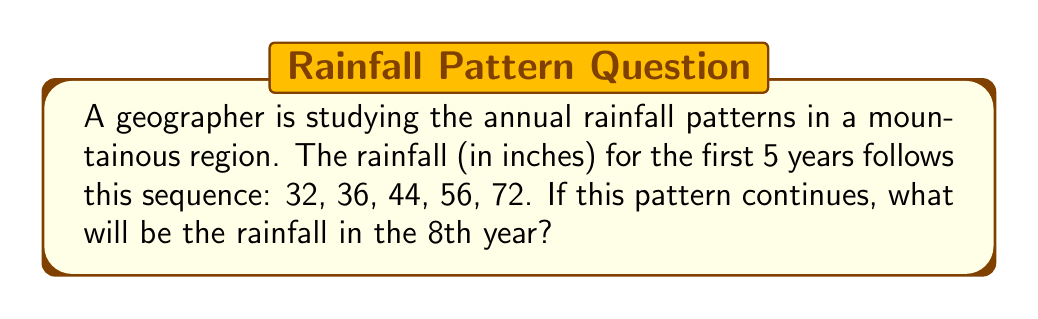Can you answer this question? To solve this problem, let's follow these steps:

1) First, we need to identify the pattern in the given sequence:
   32, 36, 44, 56, 72

2) Let's calculate the differences between consecutive terms:
   36 - 32 = 4
   44 - 36 = 8
   56 - 44 = 12
   72 - 56 = 16

3) We can see that the differences are increasing by 4 each time:
   4, 8, 12, 16

4) This suggests that the sequence is a quadratic sequence, where the second differences are constant.

5) For a quadratic sequence, we can use the formula:
   $$a_n = an^2 + bn + c$$
   where $n$ is the term number, and $a$, $b$, and $c$ are constants we need to find.

6) Using the first term (n = 1):
   $$32 = a + b + c$$

7) The second difference is constant and equal to 8. In a quadratic sequence, this is equal to 2a. So:
   $$a = 4$$

8) Now we can set up two more equations using the second and third terms:
   $$36 = 4(2^2) + 2b + c$$
   $$44 = 4(3^2) + 3b + c$$

9) Subtracting these equations:
   $$8 = 20 + b$$
   $$b = -12$$

10) Substituting back into the equation from step 6:
    $$32 = 4 - 12 + c$$
    $$c = 40$$

11) So our sequence formula is:
    $$a_n = 4n^2 - 12n + 40$$

12) For the 8th year, n = 8:
    $$a_8 = 4(8^2) - 12(8) + 40$$
    $$a_8 = 4(64) - 96 + 40$$
    $$a_8 = 256 - 96 + 40$$
    $$a_8 = 200$$

Therefore, the rainfall in the 8th year will be 200 inches.
Answer: 200 inches 